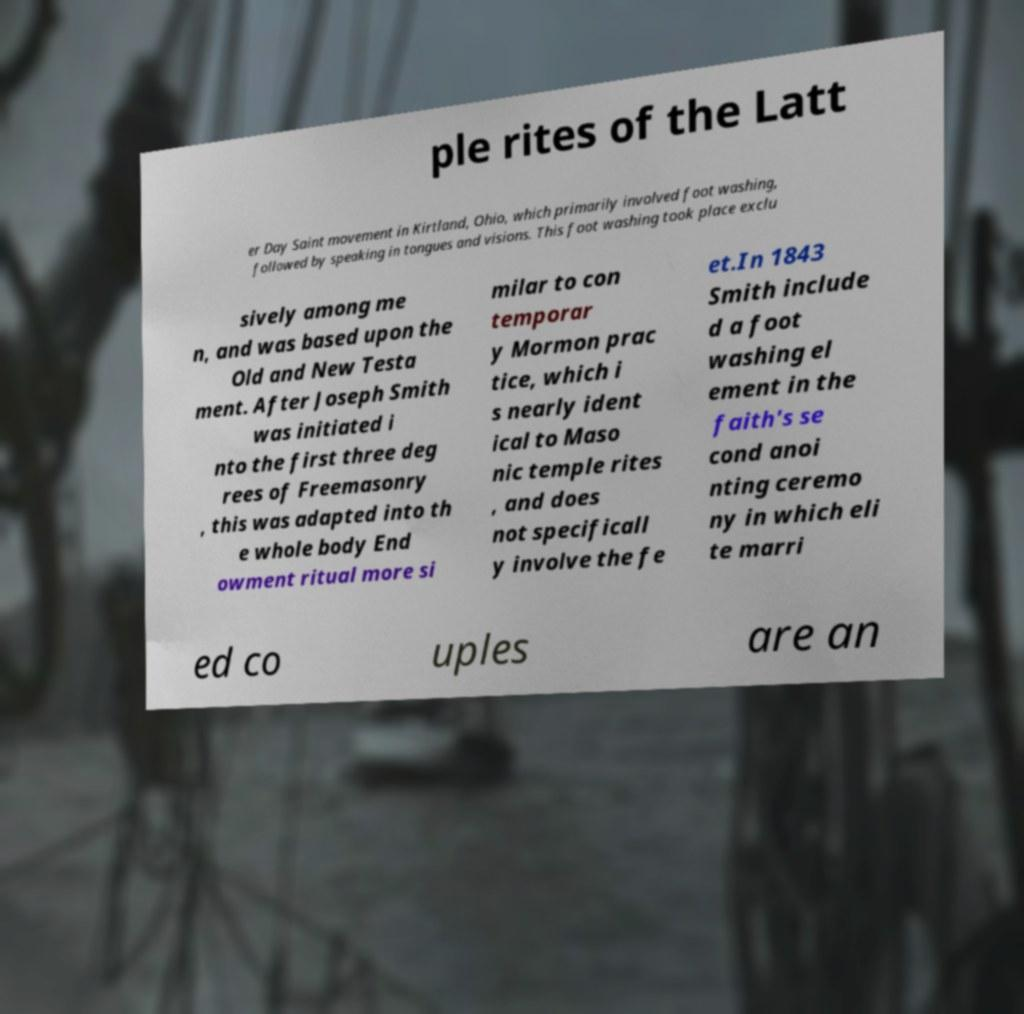I need the written content from this picture converted into text. Can you do that? ple rites of the Latt er Day Saint movement in Kirtland, Ohio, which primarily involved foot washing, followed by speaking in tongues and visions. This foot washing took place exclu sively among me n, and was based upon the Old and New Testa ment. After Joseph Smith was initiated i nto the first three deg rees of Freemasonry , this was adapted into th e whole body End owment ritual more si milar to con temporar y Mormon prac tice, which i s nearly ident ical to Maso nic temple rites , and does not specificall y involve the fe et.In 1843 Smith include d a foot washing el ement in the faith's se cond anoi nting ceremo ny in which eli te marri ed co uples are an 